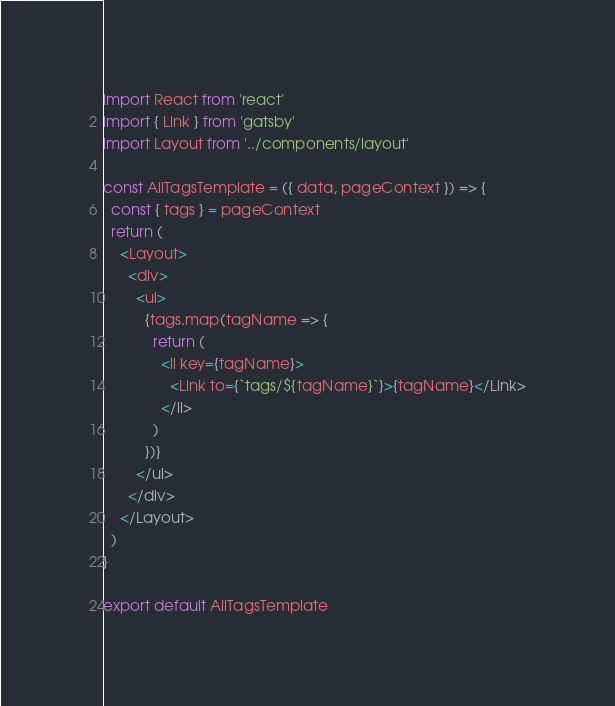<code> <loc_0><loc_0><loc_500><loc_500><_JavaScript_>import React from 'react'
import { Link } from 'gatsby'
import Layout from '../components/layout'

const AllTagsTemplate = ({ data, pageContext }) => {
  const { tags } = pageContext
  return (
    <Layout>
      <div>
        <ul>
          {tags.map(tagName => {
            return (
              <li key={tagName}>
                <Link to={`tags/${tagName}`}>{tagName}</Link>
              </li>
            )
          })}
        </ul>
      </div>
    </Layout>
  )
}

export default AllTagsTemplate
</code> 